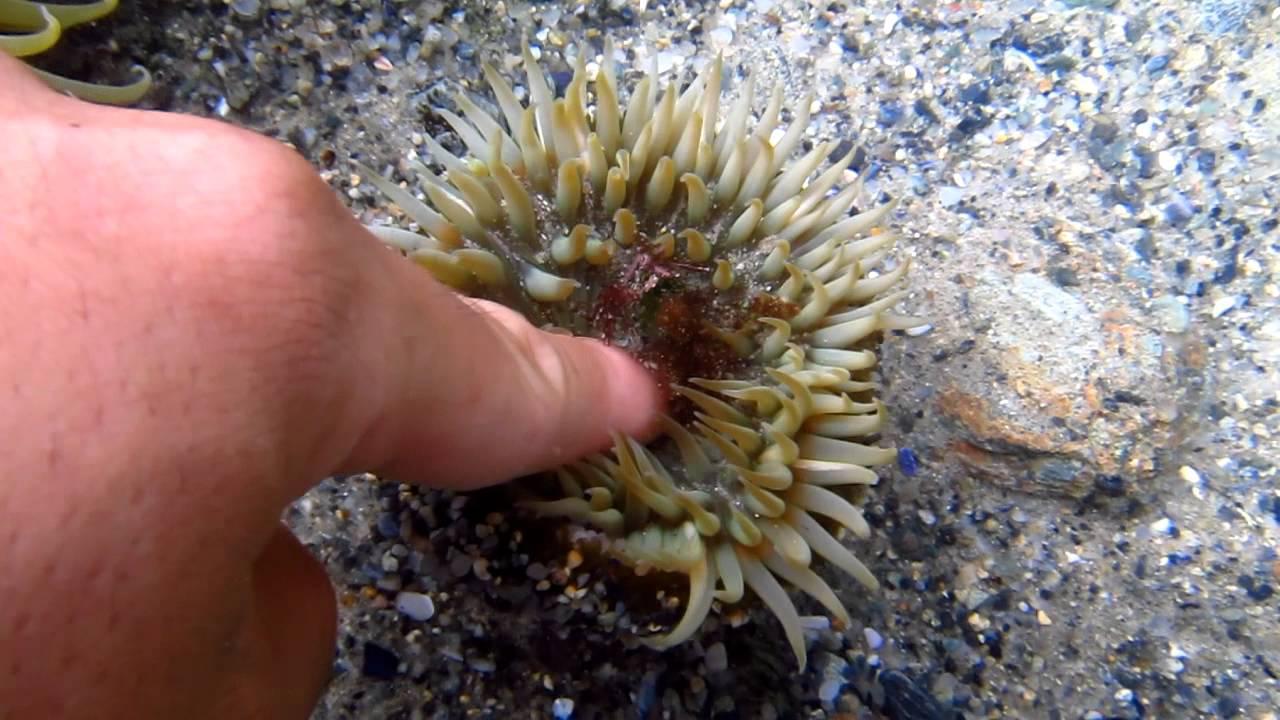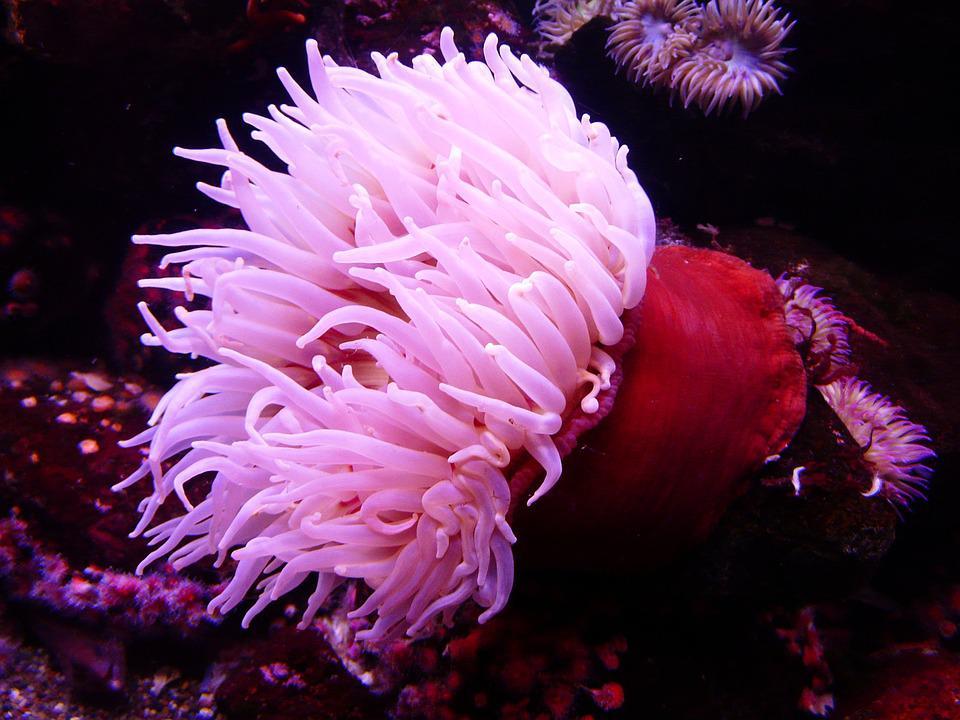The first image is the image on the left, the second image is the image on the right. For the images shown, is this caption "Both images show anemones with similar vibrant warm coloring." true? Answer yes or no. No. 